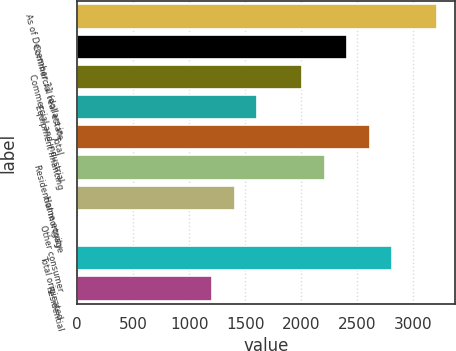Convert chart to OTSL. <chart><loc_0><loc_0><loc_500><loc_500><bar_chart><fcel>As of December 31 (dollars in<fcel>Commercial real estate<fcel>Commercial and industrial<fcel>Equipment financing<fcel>Total<fcel>Residential mortgage<fcel>Home equity<fcel>Other consumer<fcel>Total originated<fcel>Residential<nl><fcel>3219.02<fcel>2414.34<fcel>2012<fcel>1609.66<fcel>2615.51<fcel>2213.17<fcel>1408.49<fcel>0.3<fcel>2816.68<fcel>1207.32<nl></chart> 